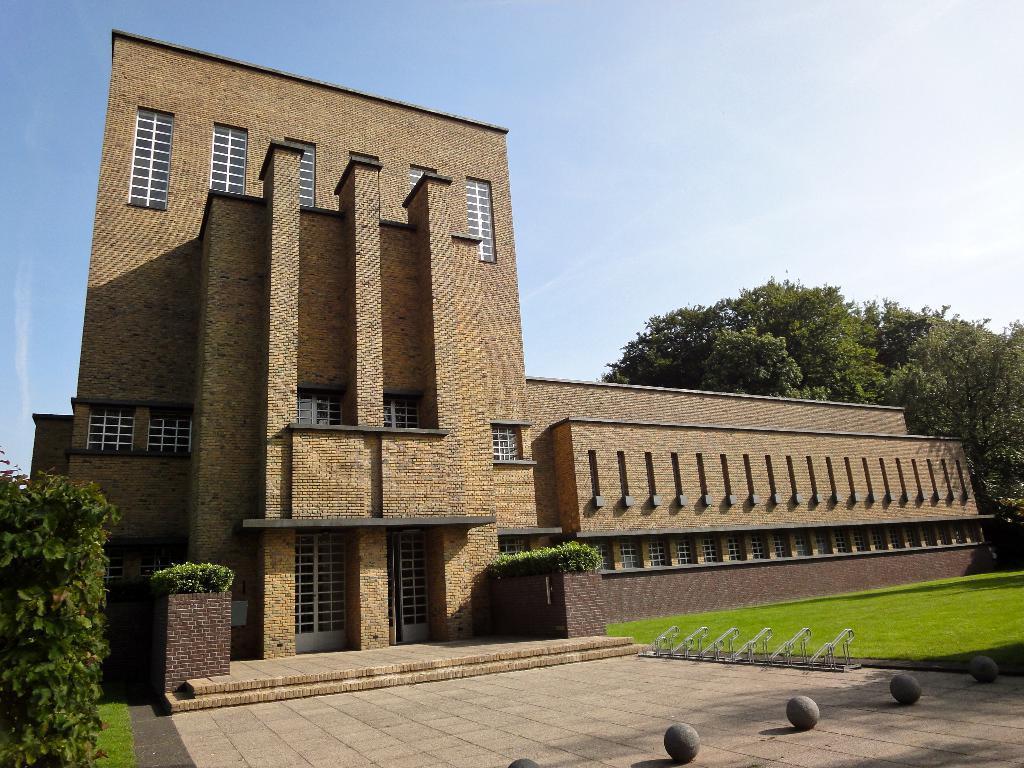Could you give a brief overview of what you see in this image? In this image, there is an outside view. In the foreground, there is a building. There is a tree on the right side of the image. In the background, there is a sky. 